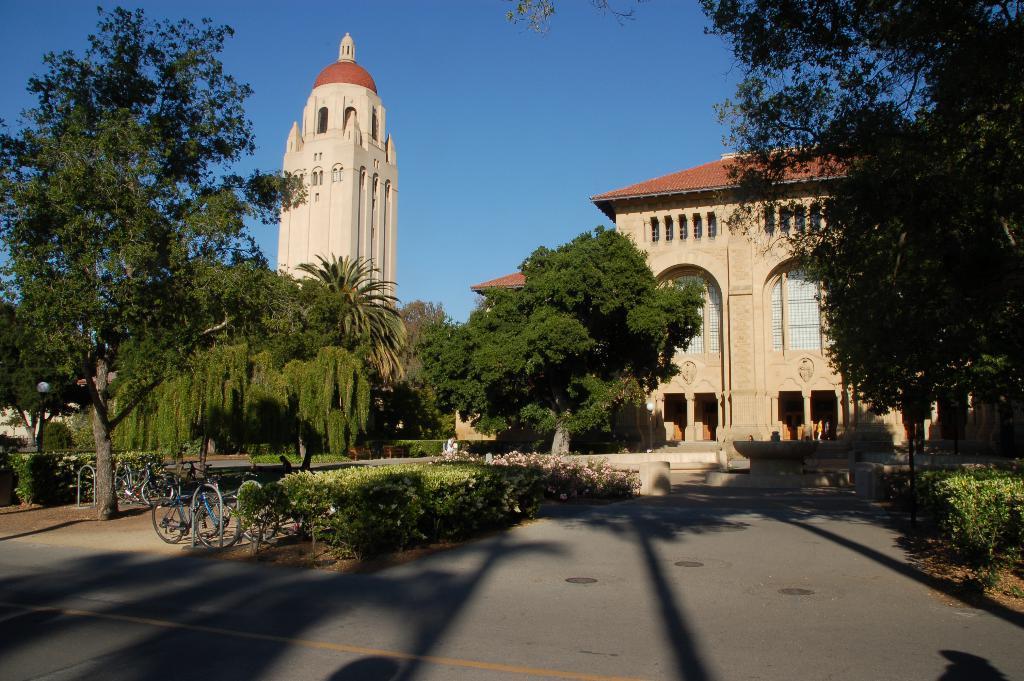Could you give a brief overview of what you see in this image? In the foreground of this image, there is a road. In the middle, there are trees, buildings, plants and the bicycles. At the top, there is the sky. 